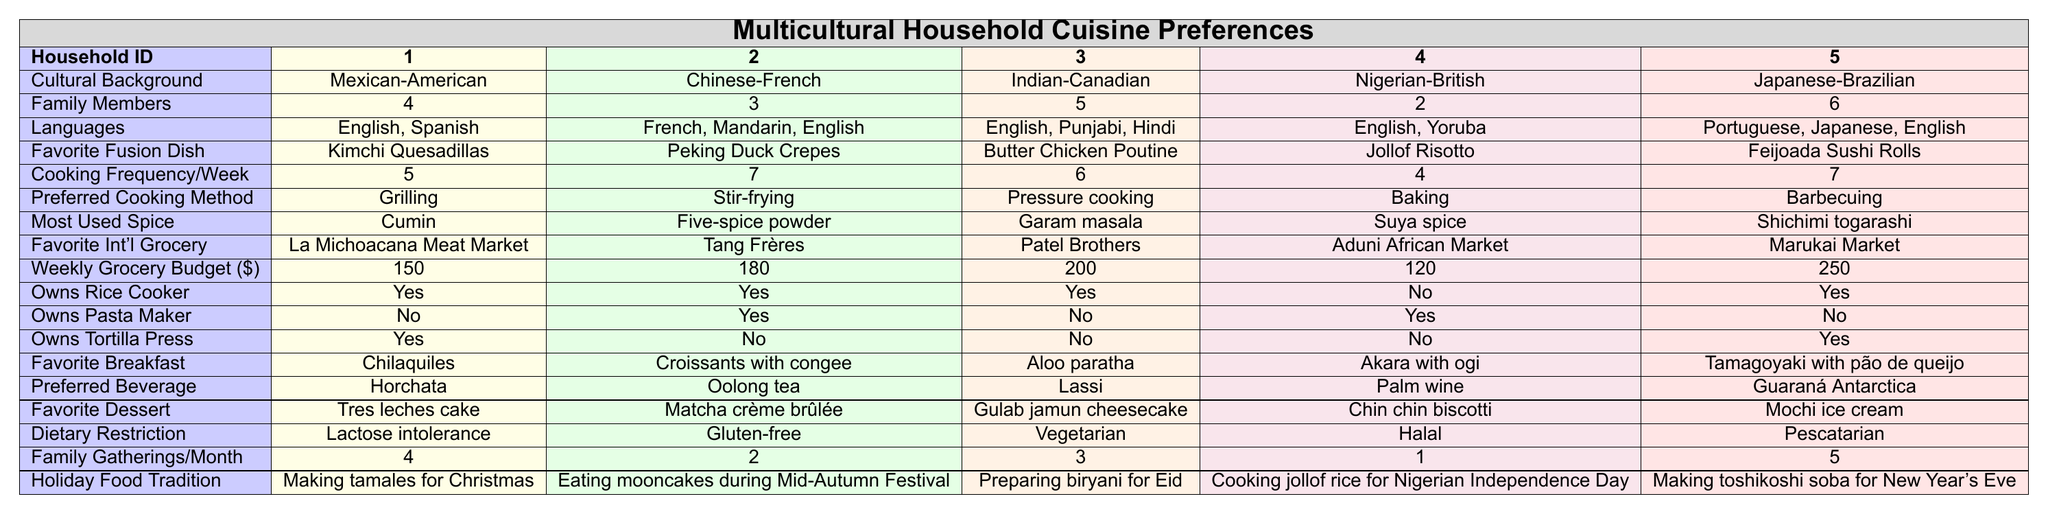What is the most common favorite breakfast item across the households? From the table, the favorite breakfast items listed are Chilaquiles, Croissants with congee, Aloo paratha, Akara with ogi, and Tamagoyaki with pão de queijo. Since they are all unique to their respective households, there is no common favorite among them.
Answer: No common favorite Which household has the highest weekly grocery budget? Looking at the weekly grocery budget values, they are $150, $180, $200, $120, and $250. Here, $250 is the highest value, belonging to the Japanese-Brazilian household (Household 5).
Answer: Household 5 How many households own a rice cooker? The table shows that four households own a rice cooker (Households 1, 2, 3, and 5). Household 4 does not own one. Counting the "Yes" responses gives four households.
Answer: 4 What is the favorite fusion dish of the Nigerian-British household? Referring to the row for Household 4, the favorite fusion dish listed is "Jollof Risotto."
Answer: Jollof Risotto Which household has the least number of family members, and how many are there? Household 4 has 2 family members, making it the household with the least number of family members when comparing all the values (4, 3, 5, 2, 6).
Answer: Household 4, 2 members Is there any household that owns both a pasta maker and a tortilla press? According to the table, Household 2 owns a pasta maker but does not own a tortilla press. Households 1 and 5 own a tortilla press but do not own a pasta maker. Thus, none of the households own both appliances.
Answer: No What is the average cooking frequency per week across the households? To calculate the average, we add the weekly cooking frequencies: 5 + 7 + 6 + 4 + 7 = 29. Dividing by the number of households (5) gives 29/5 = 5.8.
Answer: 5.8 Which household prefers grilling as a cooking method and how many family members do they have? Looking at the preferred cooking methods, Household 1 prefers grilling and has 4 family members according to the family members count in the table.
Answer: Household 1, 4 members How many households have a dietary restriction of “Vegetarian”? Only Household 3 has a dietary restriction of "Vegetarian" based on the provided data in the respective row.
Answer: 1 Which household traditions include food related to a holiday and what is that food? Household 1's holiday tradition is making tamales for Christmas, Household 2's is eating mooncakes during Mid-Autumn Festival, Household 3 prepares biryani for Eid, Household 4 cooks jollof rice for Nigerian Independence Day, and Household 5 makes toshikoshi soba for New Year's Eve. Each household has a unique holiday food tradition.
Answer: All households have unique traditions 